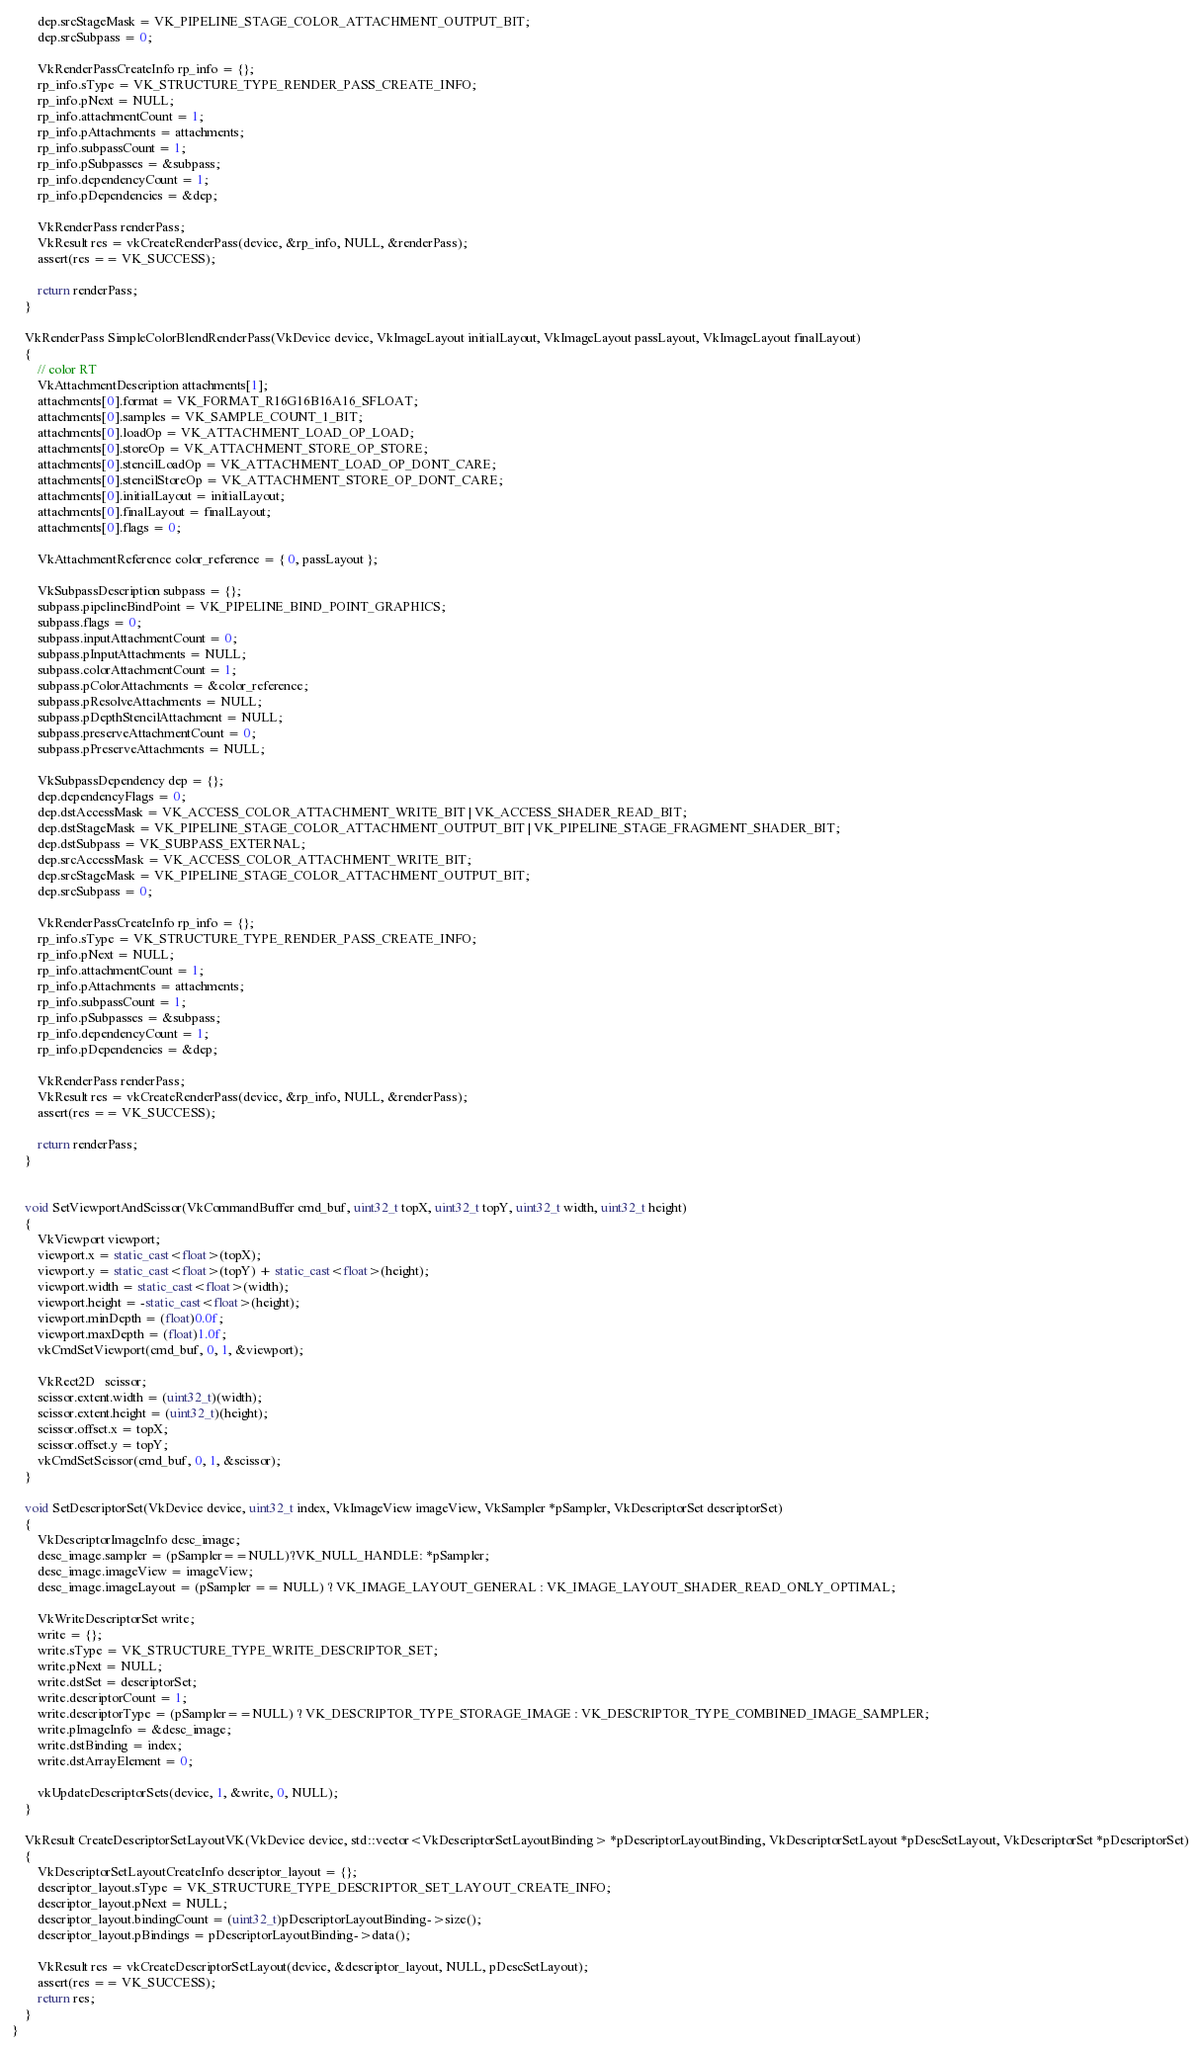<code> <loc_0><loc_0><loc_500><loc_500><_C++_>        dep.srcStageMask = VK_PIPELINE_STAGE_COLOR_ATTACHMENT_OUTPUT_BIT;
        dep.srcSubpass = 0;

        VkRenderPassCreateInfo rp_info = {};
        rp_info.sType = VK_STRUCTURE_TYPE_RENDER_PASS_CREATE_INFO;
        rp_info.pNext = NULL;
        rp_info.attachmentCount = 1;
        rp_info.pAttachments = attachments;
        rp_info.subpassCount = 1;
        rp_info.pSubpasses = &subpass;
        rp_info.dependencyCount = 1;
        rp_info.pDependencies = &dep;

        VkRenderPass renderPass;
        VkResult res = vkCreateRenderPass(device, &rp_info, NULL, &renderPass);
        assert(res == VK_SUCCESS);

        return renderPass;
    }

    VkRenderPass SimpleColorBlendRenderPass(VkDevice device, VkImageLayout initialLayout, VkImageLayout passLayout, VkImageLayout finalLayout)
    {
        // color RT
        VkAttachmentDescription attachments[1];
        attachments[0].format = VK_FORMAT_R16G16B16A16_SFLOAT;
        attachments[0].samples = VK_SAMPLE_COUNT_1_BIT;
        attachments[0].loadOp = VK_ATTACHMENT_LOAD_OP_LOAD;
        attachments[0].storeOp = VK_ATTACHMENT_STORE_OP_STORE;
        attachments[0].stencilLoadOp = VK_ATTACHMENT_LOAD_OP_DONT_CARE;
        attachments[0].stencilStoreOp = VK_ATTACHMENT_STORE_OP_DONT_CARE;
        attachments[0].initialLayout = initialLayout;
        attachments[0].finalLayout = finalLayout;
        attachments[0].flags = 0;

        VkAttachmentReference color_reference = { 0, passLayout };

        VkSubpassDescription subpass = {};
        subpass.pipelineBindPoint = VK_PIPELINE_BIND_POINT_GRAPHICS;
        subpass.flags = 0;
        subpass.inputAttachmentCount = 0;
        subpass.pInputAttachments = NULL;
        subpass.colorAttachmentCount = 1;
        subpass.pColorAttachments = &color_reference;
        subpass.pResolveAttachments = NULL;
        subpass.pDepthStencilAttachment = NULL;
        subpass.preserveAttachmentCount = 0;
        subpass.pPreserveAttachments = NULL;

        VkSubpassDependency dep = {};
        dep.dependencyFlags = 0;
        dep.dstAccessMask = VK_ACCESS_COLOR_ATTACHMENT_WRITE_BIT | VK_ACCESS_SHADER_READ_BIT;
        dep.dstStageMask = VK_PIPELINE_STAGE_COLOR_ATTACHMENT_OUTPUT_BIT | VK_PIPELINE_STAGE_FRAGMENT_SHADER_BIT;
        dep.dstSubpass = VK_SUBPASS_EXTERNAL;
        dep.srcAccessMask = VK_ACCESS_COLOR_ATTACHMENT_WRITE_BIT;
        dep.srcStageMask = VK_PIPELINE_STAGE_COLOR_ATTACHMENT_OUTPUT_BIT;
        dep.srcSubpass = 0;

        VkRenderPassCreateInfo rp_info = {};
        rp_info.sType = VK_STRUCTURE_TYPE_RENDER_PASS_CREATE_INFO;
        rp_info.pNext = NULL;
        rp_info.attachmentCount = 1;
        rp_info.pAttachments = attachments;
        rp_info.subpassCount = 1;
        rp_info.pSubpasses = &subpass;
        rp_info.dependencyCount = 1;
        rp_info.pDependencies = &dep;

        VkRenderPass renderPass;
        VkResult res = vkCreateRenderPass(device, &rp_info, NULL, &renderPass);
        assert(res == VK_SUCCESS);

        return renderPass;
    }


    void SetViewportAndScissor(VkCommandBuffer cmd_buf, uint32_t topX, uint32_t topY, uint32_t width, uint32_t height)
    {
        VkViewport viewport;
        viewport.x = static_cast<float>(topX);
        viewport.y = static_cast<float>(topY) + static_cast<float>(height);
        viewport.width = static_cast<float>(width);
        viewport.height = -static_cast<float>(height);
        viewport.minDepth = (float)0.0f;
        viewport.maxDepth = (float)1.0f;
        vkCmdSetViewport(cmd_buf, 0, 1, &viewport);

        VkRect2D   scissor;
        scissor.extent.width = (uint32_t)(width);
        scissor.extent.height = (uint32_t)(height);
        scissor.offset.x = topX;
        scissor.offset.y = topY;
        vkCmdSetScissor(cmd_buf, 0, 1, &scissor);
    }

    void SetDescriptorSet(VkDevice device, uint32_t index, VkImageView imageView, VkSampler *pSampler, VkDescriptorSet descriptorSet)
    {
        VkDescriptorImageInfo desc_image;
        desc_image.sampler = (pSampler==NULL)?VK_NULL_HANDLE: *pSampler;
        desc_image.imageView = imageView;
        desc_image.imageLayout = (pSampler == NULL) ? VK_IMAGE_LAYOUT_GENERAL : VK_IMAGE_LAYOUT_SHADER_READ_ONLY_OPTIMAL;

        VkWriteDescriptorSet write;
        write = {};
        write.sType = VK_STRUCTURE_TYPE_WRITE_DESCRIPTOR_SET;
        write.pNext = NULL;
        write.dstSet = descriptorSet;
        write.descriptorCount = 1;
        write.descriptorType = (pSampler==NULL) ? VK_DESCRIPTOR_TYPE_STORAGE_IMAGE : VK_DESCRIPTOR_TYPE_COMBINED_IMAGE_SAMPLER;
        write.pImageInfo = &desc_image;
        write.dstBinding = index;
        write.dstArrayElement = 0;

        vkUpdateDescriptorSets(device, 1, &write, 0, NULL);
    }

    VkResult CreateDescriptorSetLayoutVK(VkDevice device, std::vector<VkDescriptorSetLayoutBinding> *pDescriptorLayoutBinding, VkDescriptorSetLayout *pDescSetLayout, VkDescriptorSet *pDescriptorSet)
    {
        VkDescriptorSetLayoutCreateInfo descriptor_layout = {};
        descriptor_layout.sType = VK_STRUCTURE_TYPE_DESCRIPTOR_SET_LAYOUT_CREATE_INFO;
        descriptor_layout.pNext = NULL;
        descriptor_layout.bindingCount = (uint32_t)pDescriptorLayoutBinding->size();
        descriptor_layout.pBindings = pDescriptorLayoutBinding->data();

        VkResult res = vkCreateDescriptorSetLayout(device, &descriptor_layout, NULL, pDescSetLayout);
        assert(res == VK_SUCCESS);
        return res;
    }
}</code> 